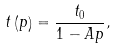Convert formula to latex. <formula><loc_0><loc_0><loc_500><loc_500>t \left ( p \right ) = \frac { t _ { 0 } } { 1 - A p } ,</formula> 